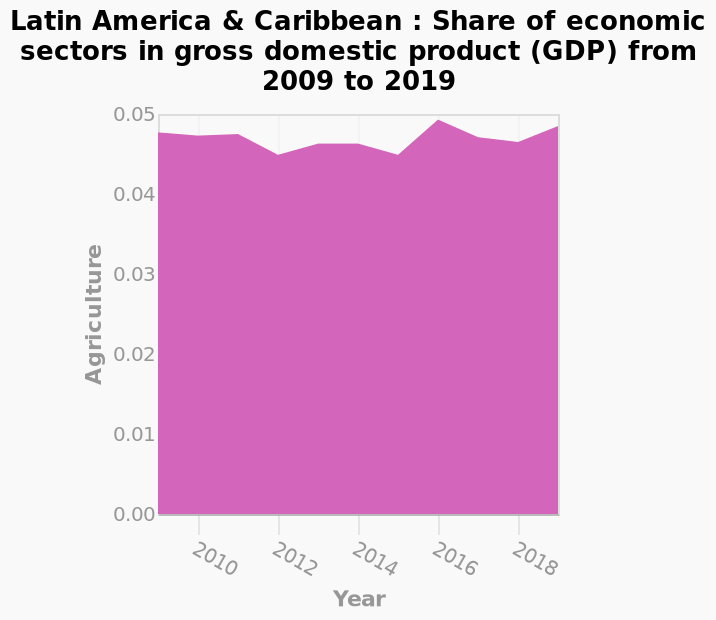<image>
please enumerates aspects of the construction of the chart Here a is a area plot named Latin America & Caribbean : Share of economic sectors in gross domestic product (GDP) from 2009 to 2019. Along the y-axis, Agriculture is plotted using a linear scale with a minimum of 0.00 and a maximum of 0.05. A linear scale with a minimum of 2010 and a maximum of 2018 can be seen along the x-axis, marked Year. What was the peak share of agriculture in gross domestic product from 2009 to 2019?  The peak share of agriculture in gross domestic product from 2009 to 2019 was approximately 0.49 in 2016. Which year had the highest share of agriculture in gross domestic product? The year with the highest share of agriculture in gross domestic product was 2016. 